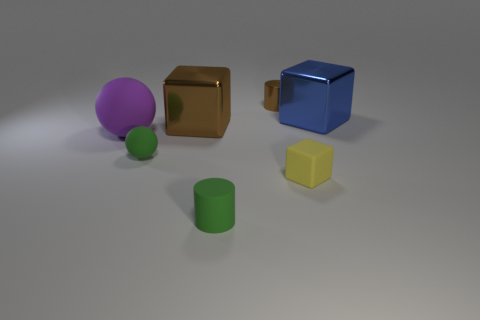Is the tiny rubber sphere the same color as the tiny rubber cylinder?
Provide a succinct answer. Yes. Are there an equal number of small brown cylinders in front of the yellow matte cube and big shiny cubes that are right of the big rubber sphere?
Your answer should be compact. No. There is a large sphere that is the same material as the small sphere; what color is it?
Your answer should be compact. Purple. What number of brown cubes are the same material as the blue object?
Your answer should be very brief. 1. Does the small cylinder in front of the tiny brown cylinder have the same color as the small sphere?
Keep it short and to the point. Yes. What number of other big metal objects are the same shape as the blue metallic thing?
Your answer should be compact. 1. Is the number of rubber objects behind the small green cylinder the same as the number of cubes?
Keep it short and to the point. Yes. What color is the other metal object that is the same size as the yellow thing?
Offer a terse response. Brown. Are there any gray matte objects of the same shape as the small brown metallic thing?
Your response must be concise. No. There is a tiny cylinder that is behind the small matte thing that is to the left of the large brown block that is behind the big matte thing; what is its material?
Offer a very short reply. Metal. 